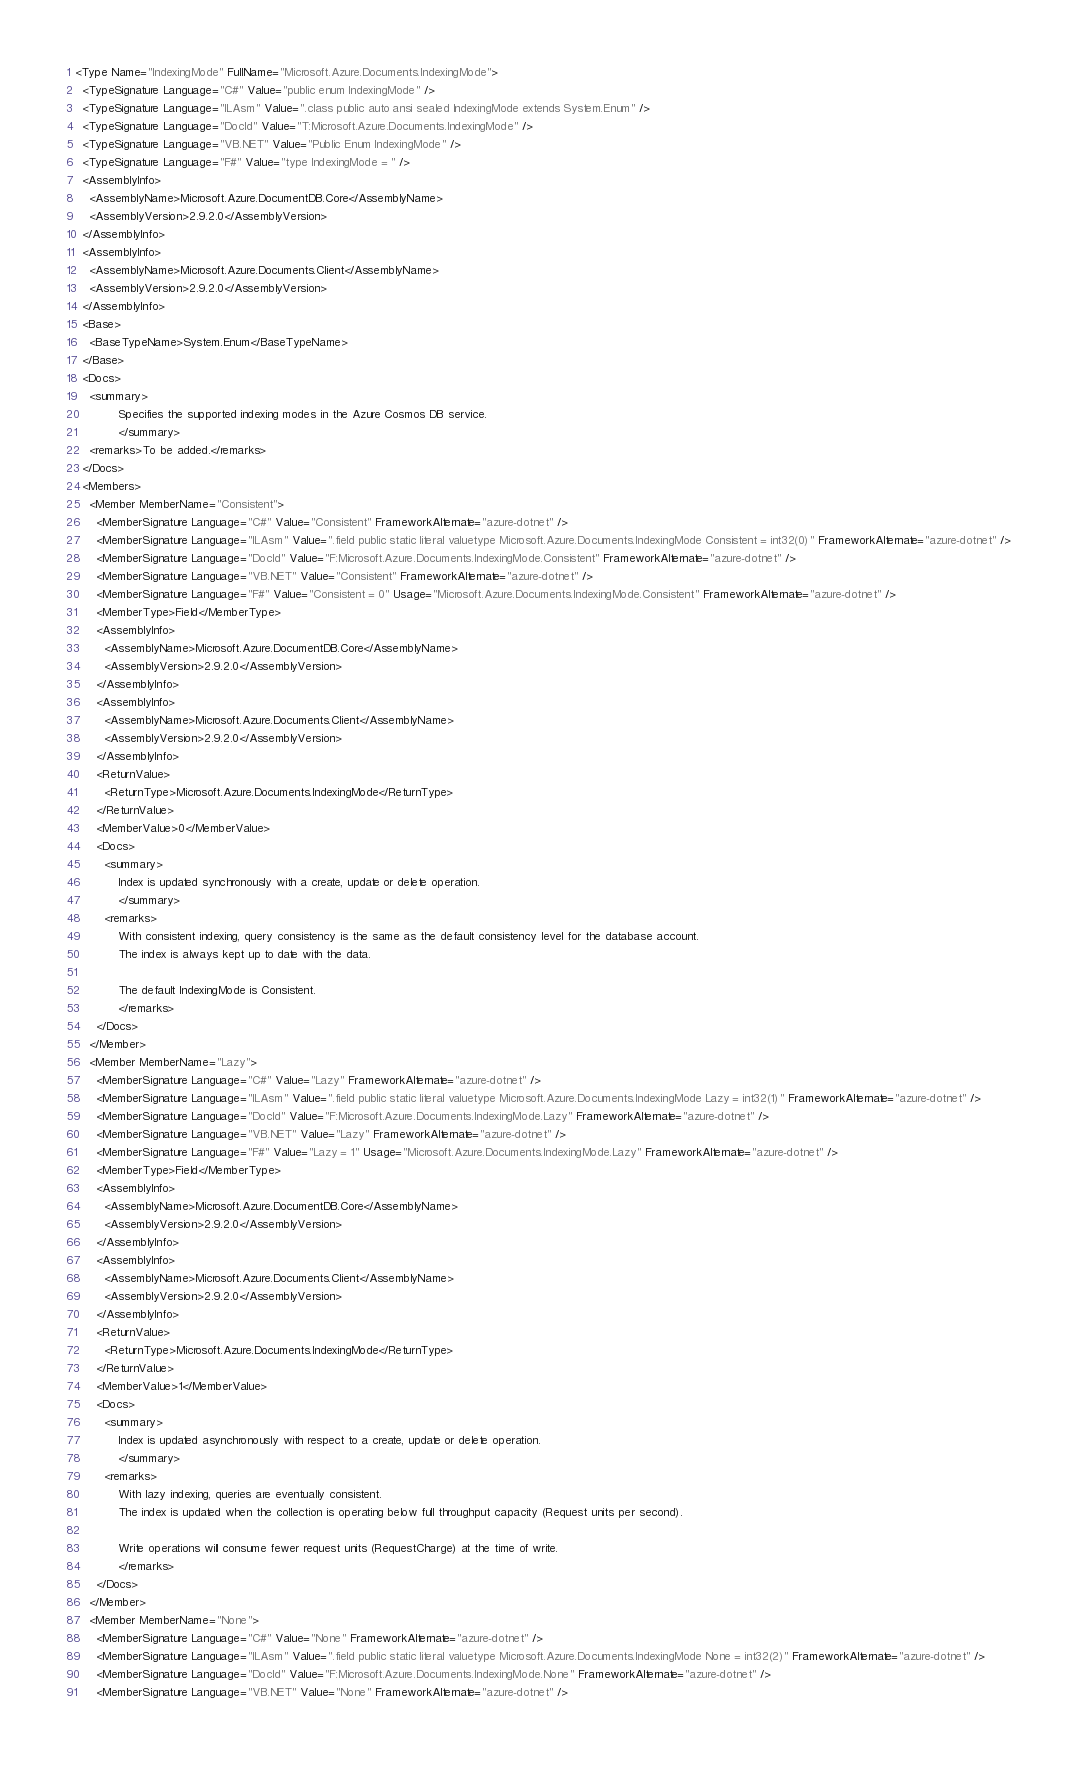Convert code to text. <code><loc_0><loc_0><loc_500><loc_500><_XML_><Type Name="IndexingMode" FullName="Microsoft.Azure.Documents.IndexingMode">
  <TypeSignature Language="C#" Value="public enum IndexingMode" />
  <TypeSignature Language="ILAsm" Value=".class public auto ansi sealed IndexingMode extends System.Enum" />
  <TypeSignature Language="DocId" Value="T:Microsoft.Azure.Documents.IndexingMode" />
  <TypeSignature Language="VB.NET" Value="Public Enum IndexingMode" />
  <TypeSignature Language="F#" Value="type IndexingMode = " />
  <AssemblyInfo>
    <AssemblyName>Microsoft.Azure.DocumentDB.Core</AssemblyName>
    <AssemblyVersion>2.9.2.0</AssemblyVersion>
  </AssemblyInfo>
  <AssemblyInfo>
    <AssemblyName>Microsoft.Azure.Documents.Client</AssemblyName>
    <AssemblyVersion>2.9.2.0</AssemblyVersion>
  </AssemblyInfo>
  <Base>
    <BaseTypeName>System.Enum</BaseTypeName>
  </Base>
  <Docs>
    <summary> 
            Specifies the supported indexing modes in the Azure Cosmos DB service.
            </summary>
    <remarks>To be added.</remarks>
  </Docs>
  <Members>
    <Member MemberName="Consistent">
      <MemberSignature Language="C#" Value="Consistent" FrameworkAlternate="azure-dotnet" />
      <MemberSignature Language="ILAsm" Value=".field public static literal valuetype Microsoft.Azure.Documents.IndexingMode Consistent = int32(0)" FrameworkAlternate="azure-dotnet" />
      <MemberSignature Language="DocId" Value="F:Microsoft.Azure.Documents.IndexingMode.Consistent" FrameworkAlternate="azure-dotnet" />
      <MemberSignature Language="VB.NET" Value="Consistent" FrameworkAlternate="azure-dotnet" />
      <MemberSignature Language="F#" Value="Consistent = 0" Usage="Microsoft.Azure.Documents.IndexingMode.Consistent" FrameworkAlternate="azure-dotnet" />
      <MemberType>Field</MemberType>
      <AssemblyInfo>
        <AssemblyName>Microsoft.Azure.DocumentDB.Core</AssemblyName>
        <AssemblyVersion>2.9.2.0</AssemblyVersion>
      </AssemblyInfo>
      <AssemblyInfo>
        <AssemblyName>Microsoft.Azure.Documents.Client</AssemblyName>
        <AssemblyVersion>2.9.2.0</AssemblyVersion>
      </AssemblyInfo>
      <ReturnValue>
        <ReturnType>Microsoft.Azure.Documents.IndexingMode</ReturnType>
      </ReturnValue>
      <MemberValue>0</MemberValue>
      <Docs>
        <summary>
            Index is updated synchronously with a create, update or delete operation.
            </summary>
        <remarks>
            With consistent indexing, query consistency is the same as the default consistency level for the database account. 
            The index is always kept up to date with the data.
            
            The default IndexingMode is Consistent.
            </remarks>
      </Docs>
    </Member>
    <Member MemberName="Lazy">
      <MemberSignature Language="C#" Value="Lazy" FrameworkAlternate="azure-dotnet" />
      <MemberSignature Language="ILAsm" Value=".field public static literal valuetype Microsoft.Azure.Documents.IndexingMode Lazy = int32(1)" FrameworkAlternate="azure-dotnet" />
      <MemberSignature Language="DocId" Value="F:Microsoft.Azure.Documents.IndexingMode.Lazy" FrameworkAlternate="azure-dotnet" />
      <MemberSignature Language="VB.NET" Value="Lazy" FrameworkAlternate="azure-dotnet" />
      <MemberSignature Language="F#" Value="Lazy = 1" Usage="Microsoft.Azure.Documents.IndexingMode.Lazy" FrameworkAlternate="azure-dotnet" />
      <MemberType>Field</MemberType>
      <AssemblyInfo>
        <AssemblyName>Microsoft.Azure.DocumentDB.Core</AssemblyName>
        <AssemblyVersion>2.9.2.0</AssemblyVersion>
      </AssemblyInfo>
      <AssemblyInfo>
        <AssemblyName>Microsoft.Azure.Documents.Client</AssemblyName>
        <AssemblyVersion>2.9.2.0</AssemblyVersion>
      </AssemblyInfo>
      <ReturnValue>
        <ReturnType>Microsoft.Azure.Documents.IndexingMode</ReturnType>
      </ReturnValue>
      <MemberValue>1</MemberValue>
      <Docs>
        <summary>
            Index is updated asynchronously with respect to a create, update or delete operation.
            </summary>
        <remarks>
            With lazy indexing, queries are eventually consistent. 
            The index is updated when the collection is operating below full throughput capacity (Request units per second). 
            
            Write operations will consume fewer request units (RequestCharge) at the time of write.
            </remarks>
      </Docs>
    </Member>
    <Member MemberName="None">
      <MemberSignature Language="C#" Value="None" FrameworkAlternate="azure-dotnet" />
      <MemberSignature Language="ILAsm" Value=".field public static literal valuetype Microsoft.Azure.Documents.IndexingMode None = int32(2)" FrameworkAlternate="azure-dotnet" />
      <MemberSignature Language="DocId" Value="F:Microsoft.Azure.Documents.IndexingMode.None" FrameworkAlternate="azure-dotnet" />
      <MemberSignature Language="VB.NET" Value="None" FrameworkAlternate="azure-dotnet" /></code> 